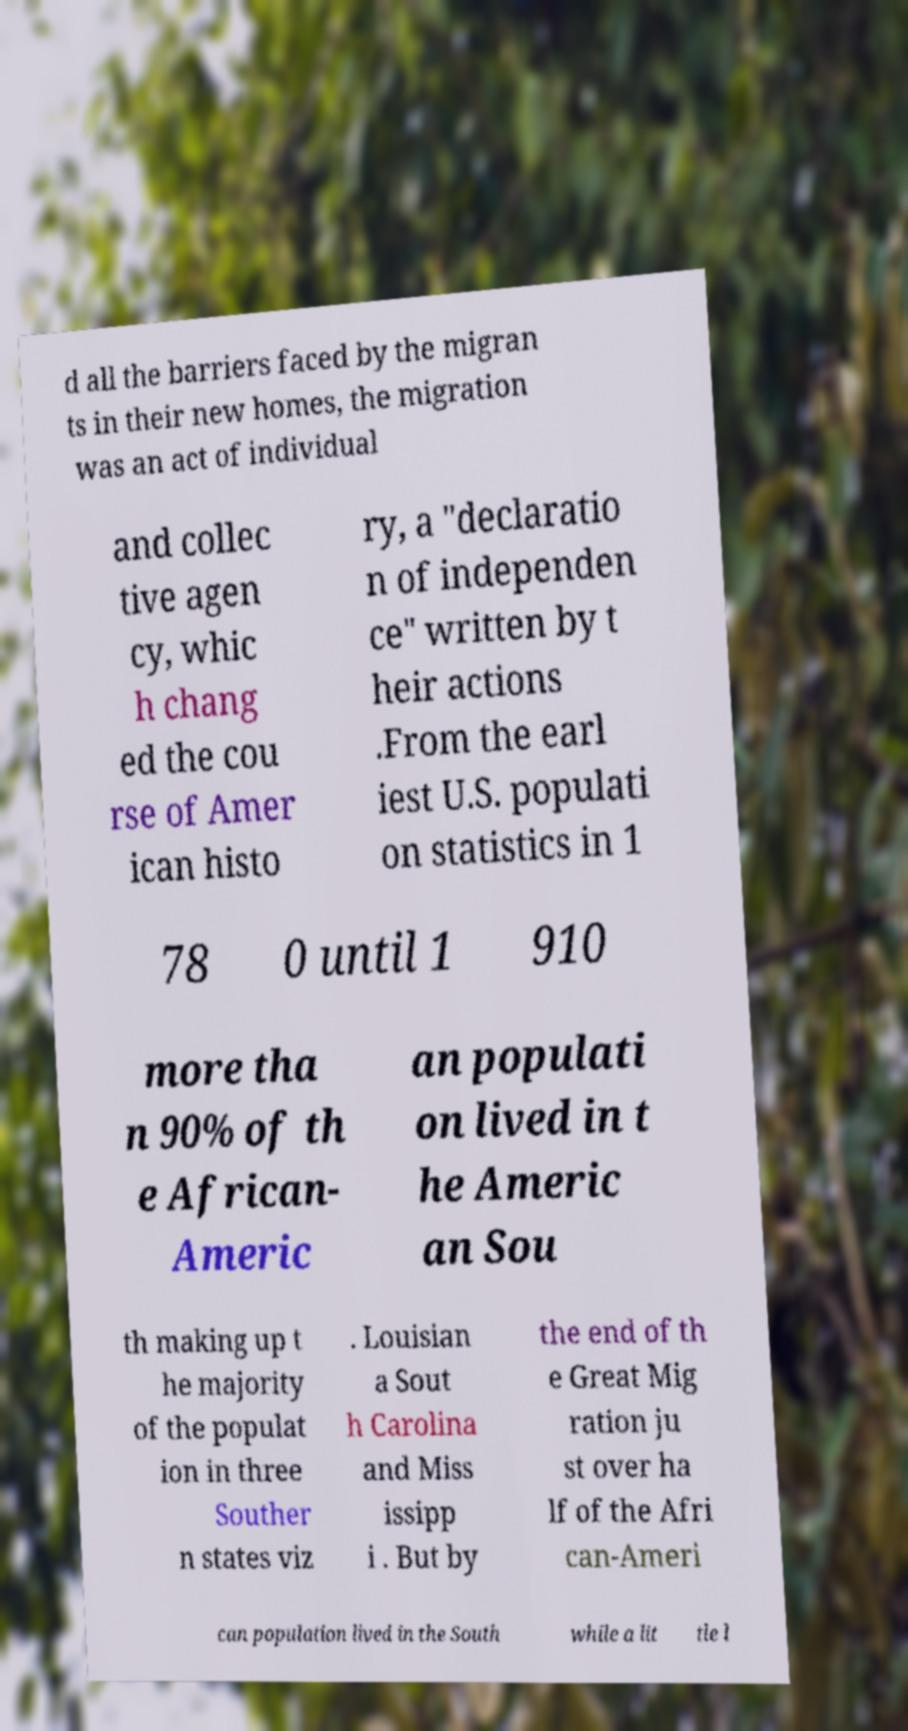Please read and relay the text visible in this image. What does it say? d all the barriers faced by the migran ts in their new homes, the migration was an act of individual and collec tive agen cy, whic h chang ed the cou rse of Amer ican histo ry, a "declaratio n of independen ce" written by t heir actions .From the earl iest U.S. populati on statistics in 1 78 0 until 1 910 more tha n 90% of th e African- Americ an populati on lived in t he Americ an Sou th making up t he majority of the populat ion in three Souther n states viz . Louisian a Sout h Carolina and Miss issipp i . But by the end of th e Great Mig ration ju st over ha lf of the Afri can-Ameri can population lived in the South while a lit tle l 